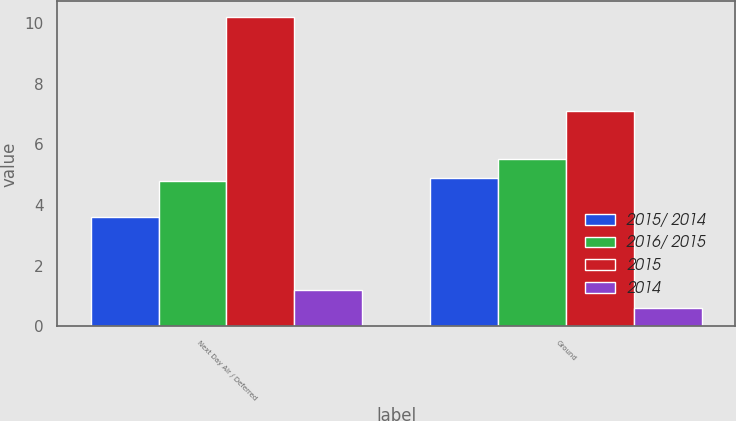<chart> <loc_0><loc_0><loc_500><loc_500><stacked_bar_chart><ecel><fcel>Next Day Air / Deferred<fcel>Ground<nl><fcel>2015/ 2014<fcel>3.6<fcel>4.9<nl><fcel>2016/ 2015<fcel>4.8<fcel>5.5<nl><fcel>2015<fcel>10.2<fcel>7.1<nl><fcel>2014<fcel>1.2<fcel>0.6<nl></chart> 